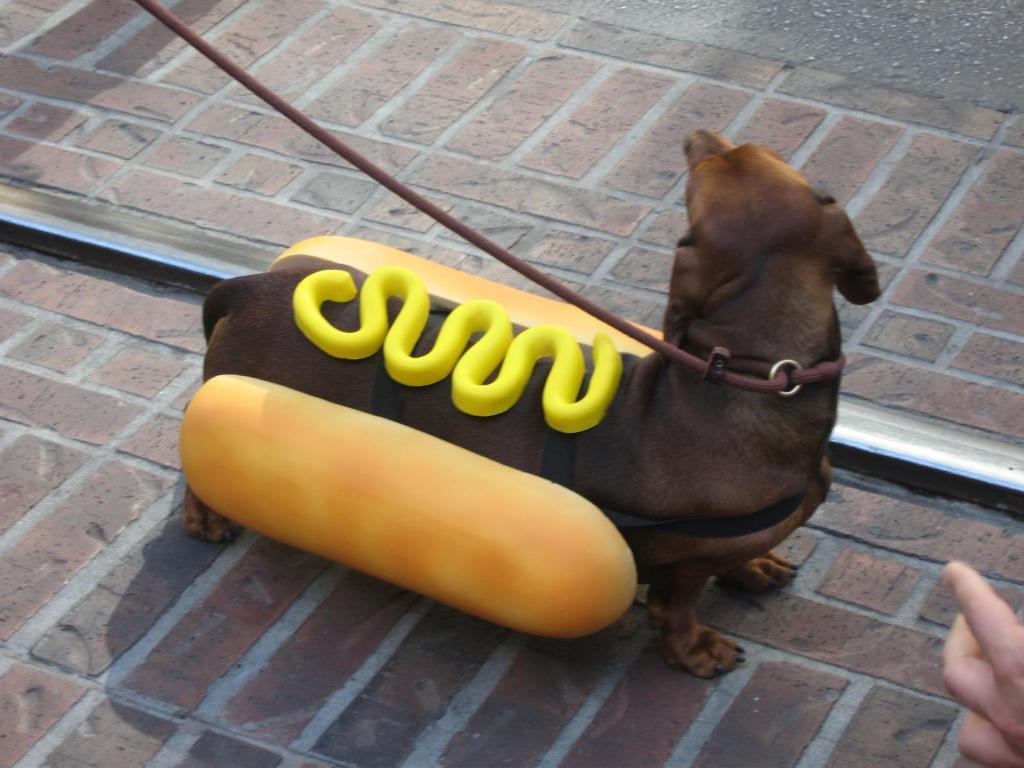What type of animal is in the image? There is a brown dog in the image. How is the dog dressed in the image? The dog is dressed as a hamburger in the image. What can be seen on top of the dog's hamburger costume? There is cheese on top of the dog's hamburger costume. What type of birds can be seen flying in the image? There are no birds visible in the image; it features a brown dog dressed as a hamburger. What type of fuel is being used by the donkey in the image? There is no donkey present in the image, so it is not possible to determine what type of fuel it might be using. 